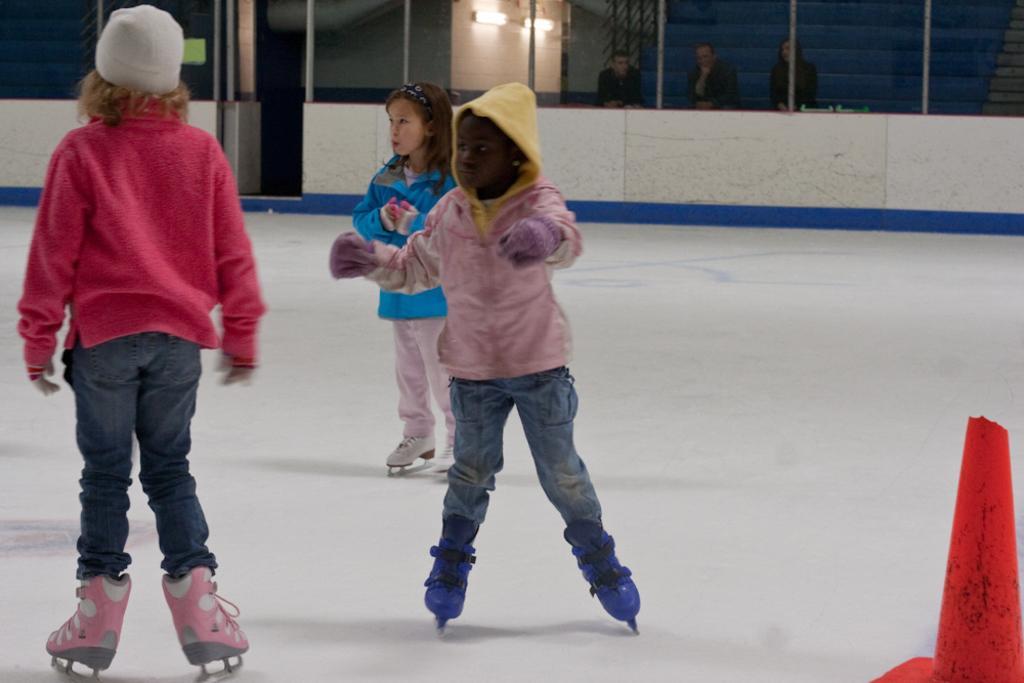Describe this image in one or two sentences. In this picture we can see three persons are figure skating, at the right bottom there is a cone, in the background we can see three persons and two lights. 